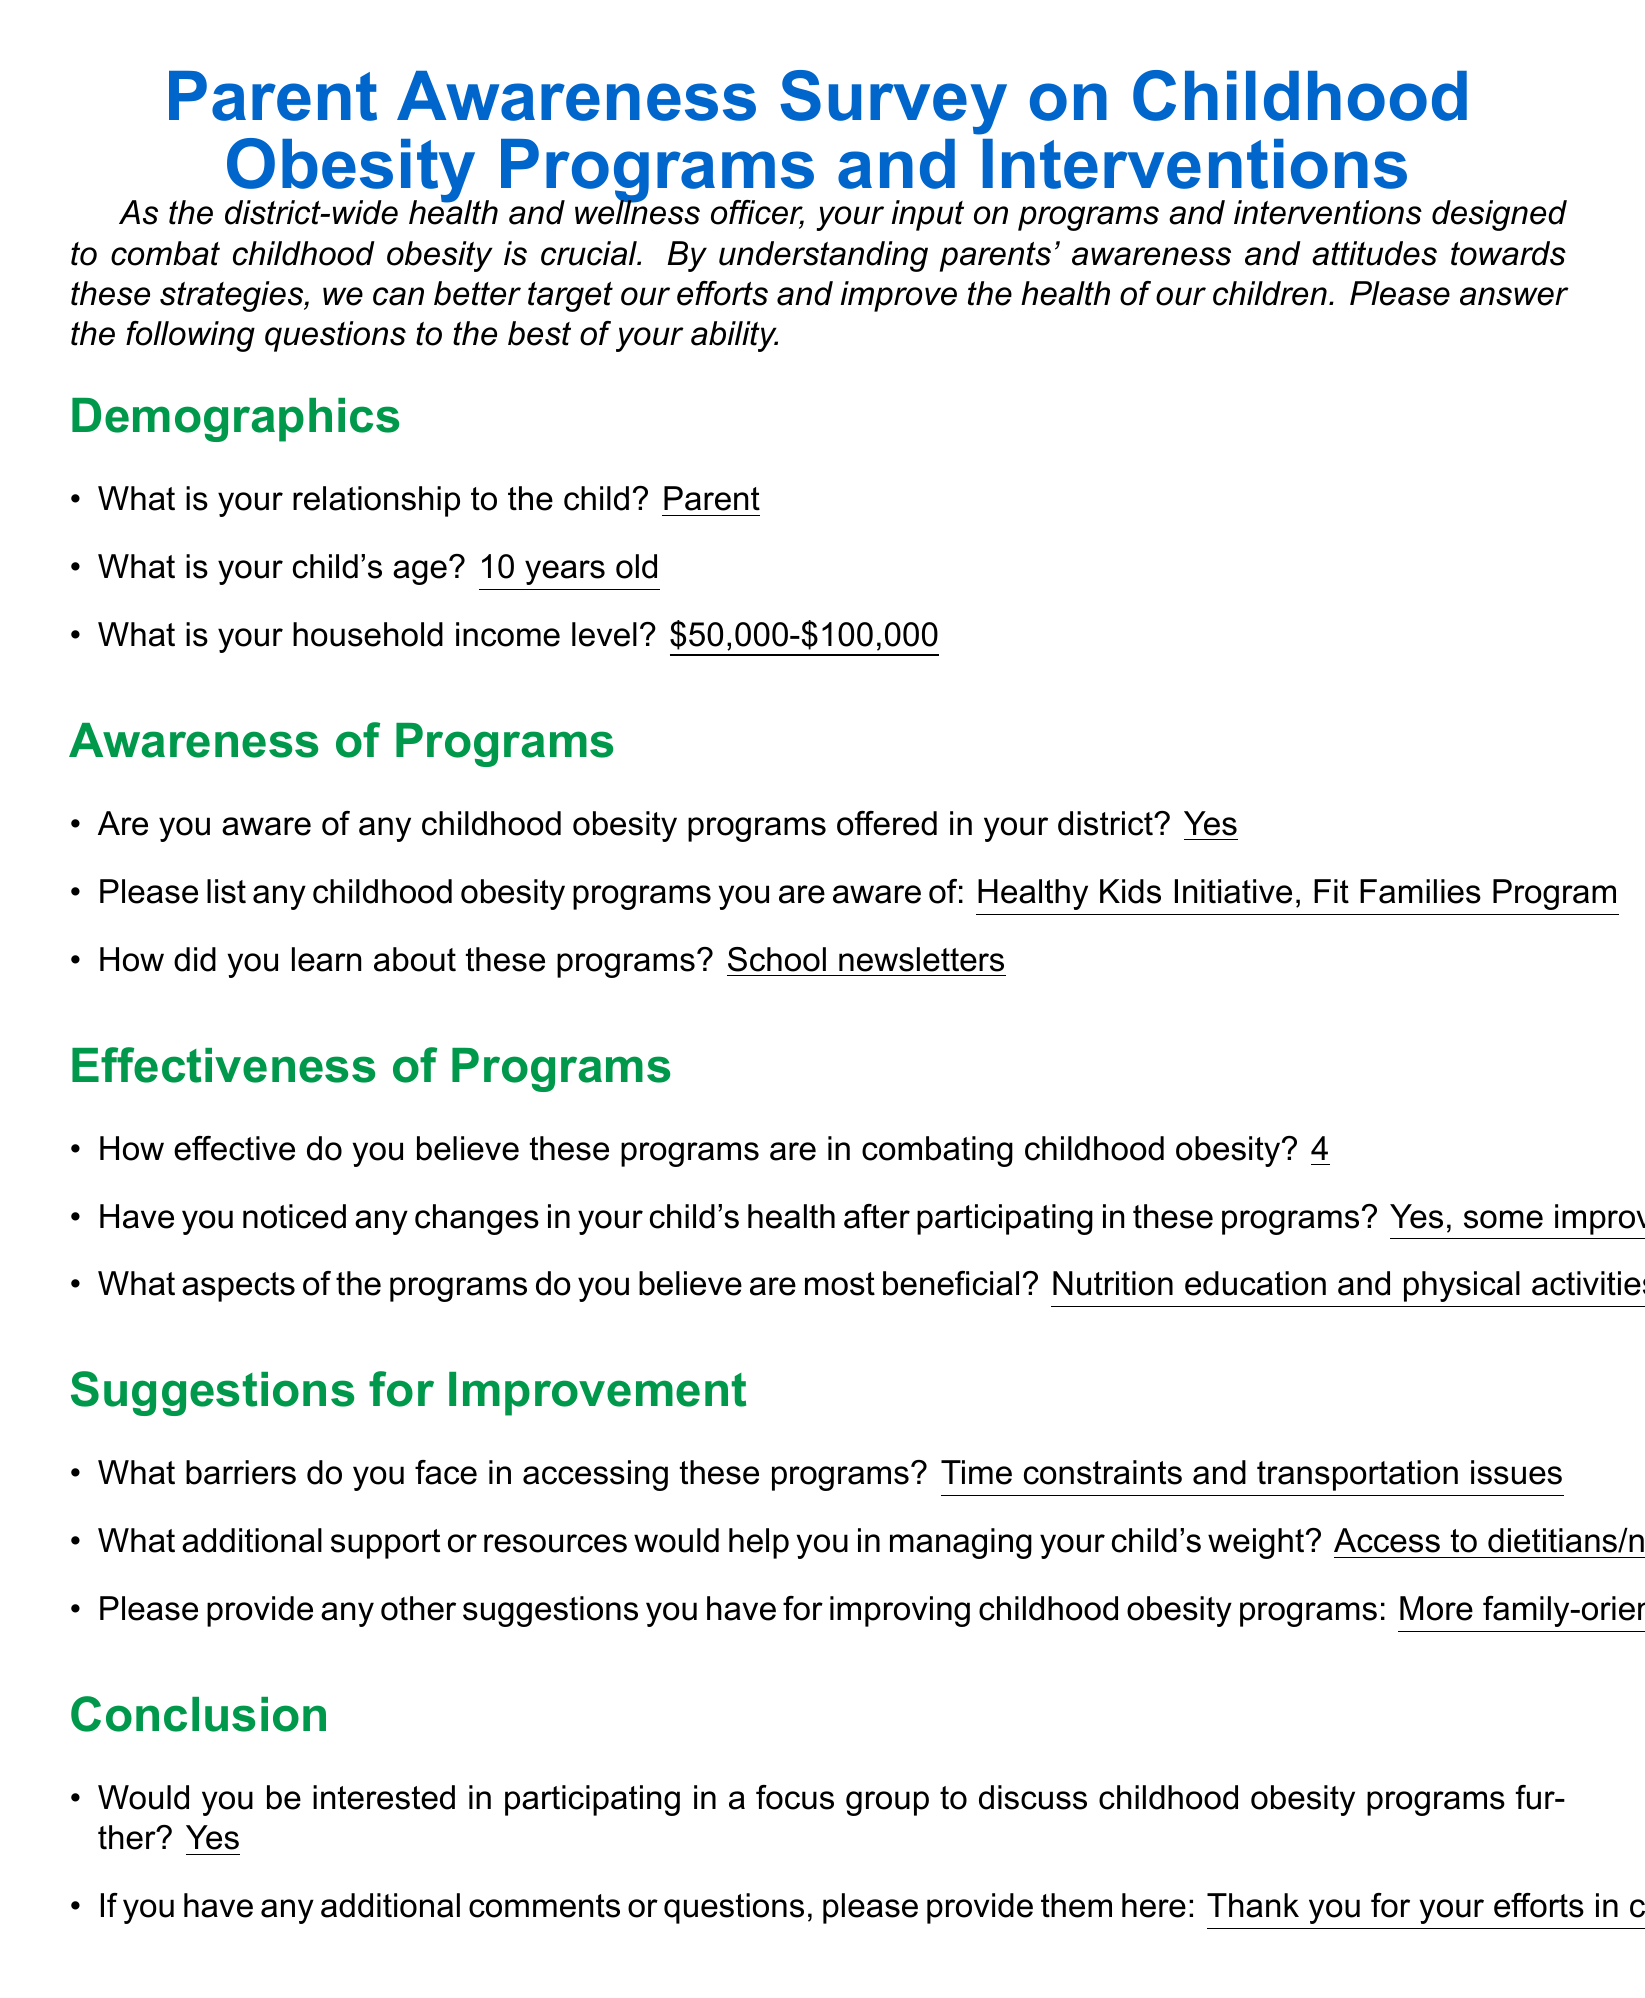What is the child's age? The child's age is specified in the demographics section of the document.
Answer: 10 years old What programs are mentioned in the awareness section? The programs listed are part of the awareness section specifically asking for known programs.
Answer: Healthy Kids Initiative, Fit Families Program How did the parent learn about the programs? The document states a specific source of information regarding how the programs were learned about.
Answer: School newsletters How effective does the parent believe these programs are? The effectiveness is rated on a scale, and the specific rating can be found in the effectiveness section.
Answer: 4 What barriers does the parent face in accessing these programs? The barriers are listed in the suggestions for improvement section.
Answer: Time constraints and transportation issues What additional support does the parent suggest for managing their child's weight? This information can be found in the suggestions for improvement section asking for additional resources.
Answer: Access to dietitians/nutritionists Is the parent interested in participating in a focus group? The conclusion section asks whether the parent would be interested in further discussion, which provides this answer.
Answer: Yes What does the parent express at the end of the survey? The parent provides a final comment that reflects their feelings about the programs.
Answer: Thank you for your efforts in combating childhood obesity! What is the household income level of the parent? The household income level is specified in the demographics section as a part of the parent’s information.
Answer: $50,000-$100,000 